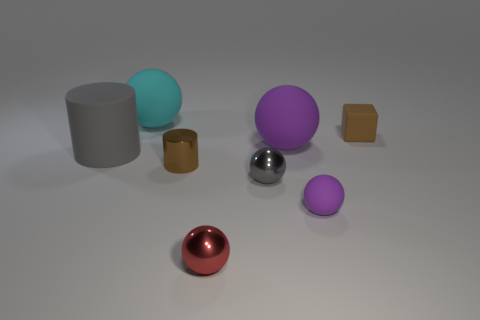Are there fewer small things to the right of the small purple matte thing than big things behind the big gray cylinder?
Your response must be concise. Yes. How many big objects are the same material as the gray ball?
Make the answer very short. 0. Are there any spheres that are to the right of the big ball behind the brown thing that is to the right of the small purple matte object?
Your answer should be very brief. Yes. What number of cubes are either purple things or metallic objects?
Ensure brevity in your answer.  0. Does the small purple thing have the same shape as the large cyan rubber object that is behind the large purple matte sphere?
Make the answer very short. Yes. Is the number of tiny brown cylinders that are in front of the small purple matte sphere less than the number of green rubber cylinders?
Provide a succinct answer. No. Are there any tiny metal spheres behind the cyan matte object?
Offer a very short reply. No. Are there any other small red metal objects of the same shape as the tiny red shiny object?
Your answer should be compact. No. The red thing that is the same size as the gray metal object is what shape?
Your response must be concise. Sphere. How many things are either rubber spheres to the left of the tiny red metallic object or large purple cylinders?
Make the answer very short. 1. 